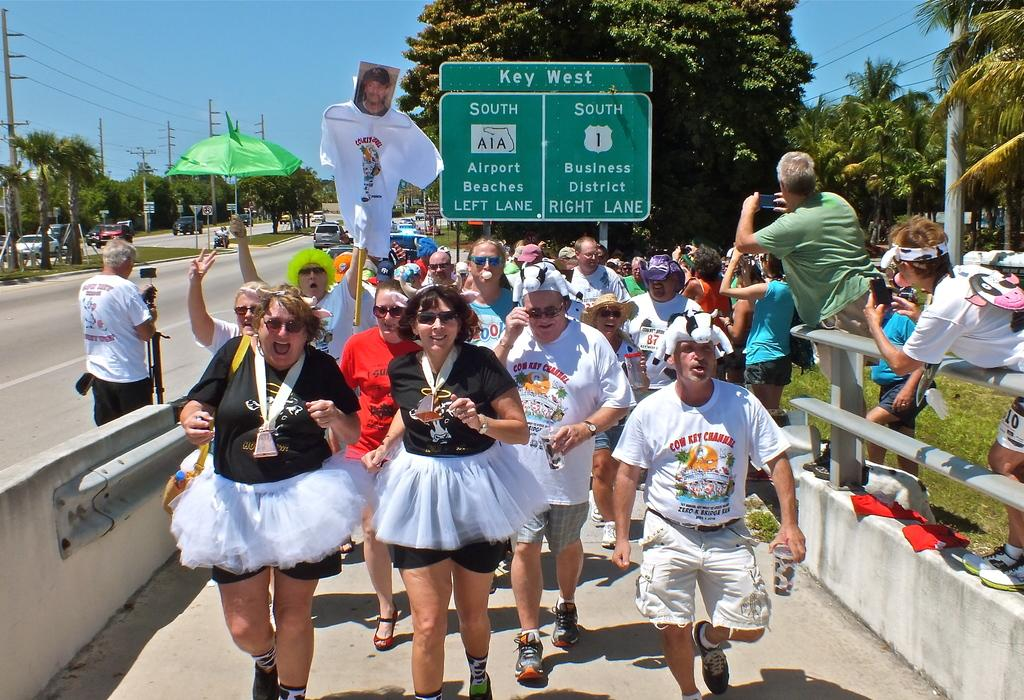What are the people in the image doing? The people in the image are running on the road. What can be seen alongside the road? Trees are present alongside the road. What type of vegetation is near the road? Grass is visible near the road. What else can be seen on the road in the image? There are vehicles on the other side of the road. What type of pan can be seen cooking food on the side of the road? There is no pan or cooking activity present in the image. Can you describe the sea visible in the background of the image? There is no sea visible in the image; it features people running on a road with trees, grass, and vehicles. 